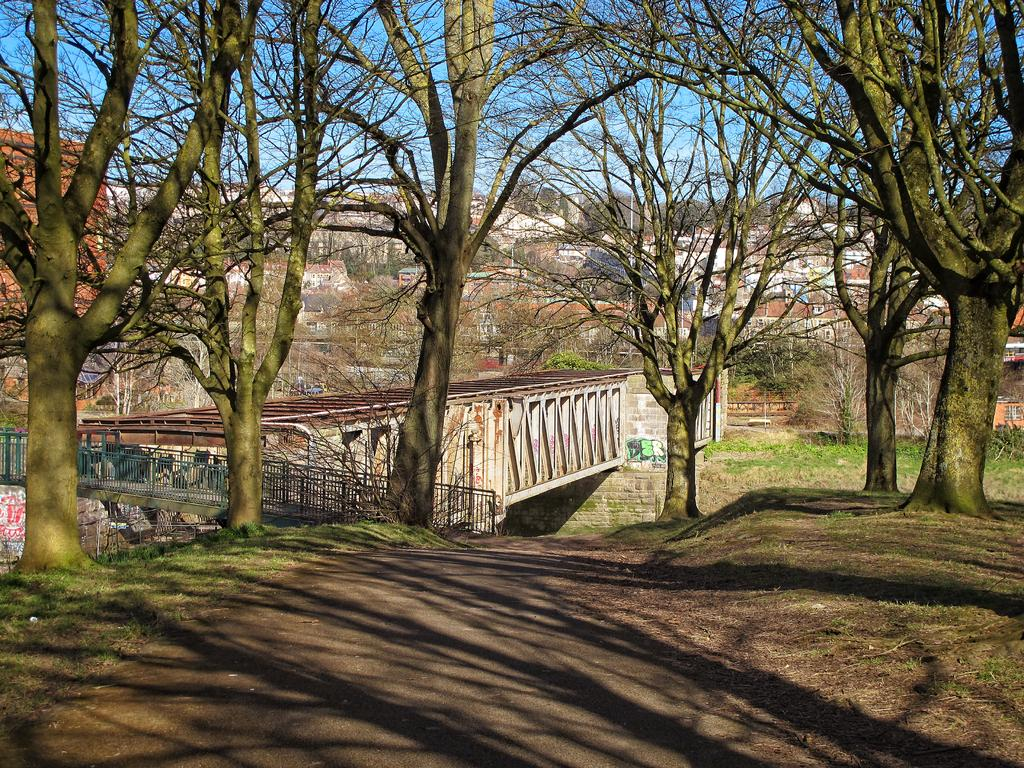What is located in the center of the image? There are trees and a bridge in the center of the image. What type of structure can be seen in the image? There are buildings in the background of the image. What is visible in the sky in the image? The sky is visible in the background of the image. What type of print can be seen on the bridge in the image? There is no print visible on the bridge in the image. Can you hear a horn in the image? There is no auditory information provided in the image, so it is impossible to determine if a horn can be heard. 